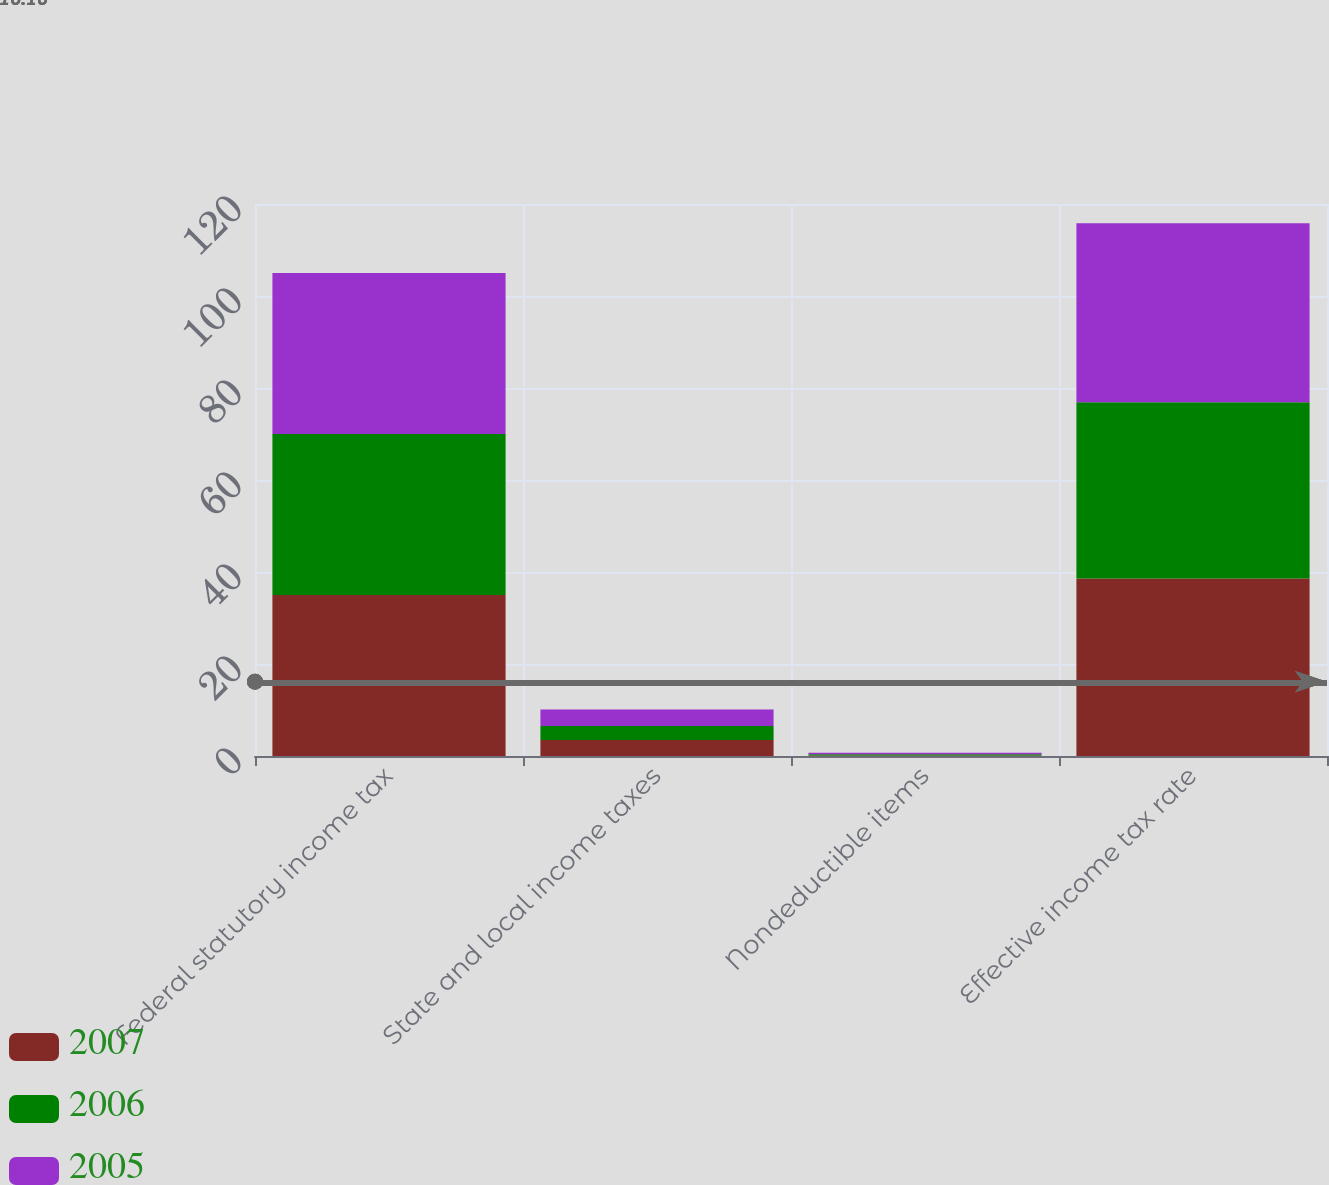Convert chart. <chart><loc_0><loc_0><loc_500><loc_500><stacked_bar_chart><ecel><fcel>Federal statutory income tax<fcel>State and local income taxes<fcel>Nondeductible items<fcel>Effective income tax rate<nl><fcel>2007<fcel>35<fcel>3.5<fcel>0.1<fcel>38.6<nl><fcel>2006<fcel>35<fcel>3<fcel>0.3<fcel>38.3<nl><fcel>2005<fcel>35<fcel>3.6<fcel>0.3<fcel>38.9<nl></chart> 